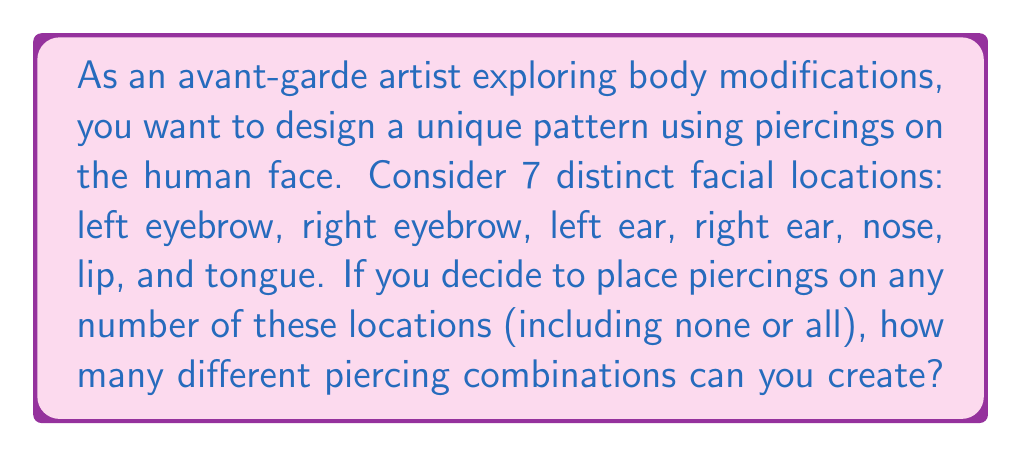Help me with this question. To solve this problem, we need to use the concept of power sets from discrete mathematics.

1) Each location has two possibilities: it either has a piercing or it doesn't.

2) We have 7 independent locations, each with 2 choices.

3) This scenario can be modeled using the multiplication principle. The total number of combinations is:

   $$2 \times 2 \times 2 \times 2 \times 2 \times 2 \times 2 = 2^7$$

4) Alternatively, we can think of this as creating a power set of a set with 7 elements. The number of subsets (including the empty set and the full set) in a power set is always $2^n$, where $n$ is the number of elements in the original set.

5) Therefore, the number of possible piercing combinations is $2^7 = 128$.

This includes:
- 1 way to have no piercings (empty set)
- 7 ways to have exactly one piercing ($\binom{7}{1}$)
- 21 ways to have exactly two piercings ($\binom{7}{2}$)
- 35 ways to have exactly three piercings ($\binom{7}{3}$)
- 35 ways to have exactly four piercings ($\binom{7}{4}$)
- 21 ways to have exactly five piercings ($\binom{7}{5}$)
- 7 ways to have exactly six piercings ($\binom{7}{6}$)
- 1 way to have all seven piercings (full set)

The sum of these is indeed $1 + 7 + 21 + 35 + 35 + 21 + 7 + 1 = 128 = 2^7$.
Answer: $2^7 = 128$ possible piercing combinations 